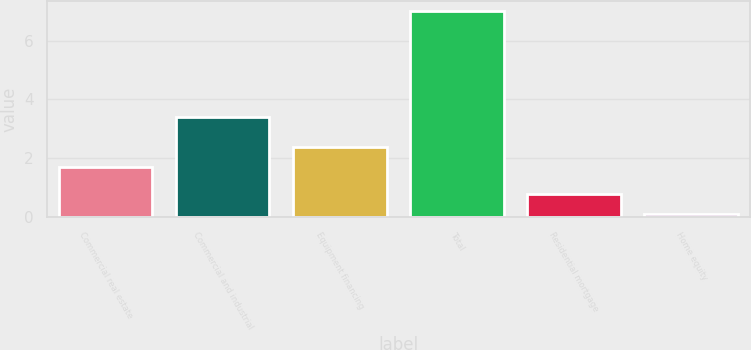Convert chart to OTSL. <chart><loc_0><loc_0><loc_500><loc_500><bar_chart><fcel>Commercial real estate<fcel>Commercial and industrial<fcel>Equipment financing<fcel>Total<fcel>Residential mortgage<fcel>Home equity<nl><fcel>1.7<fcel>3.4<fcel>2.39<fcel>7<fcel>0.79<fcel>0.1<nl></chart> 